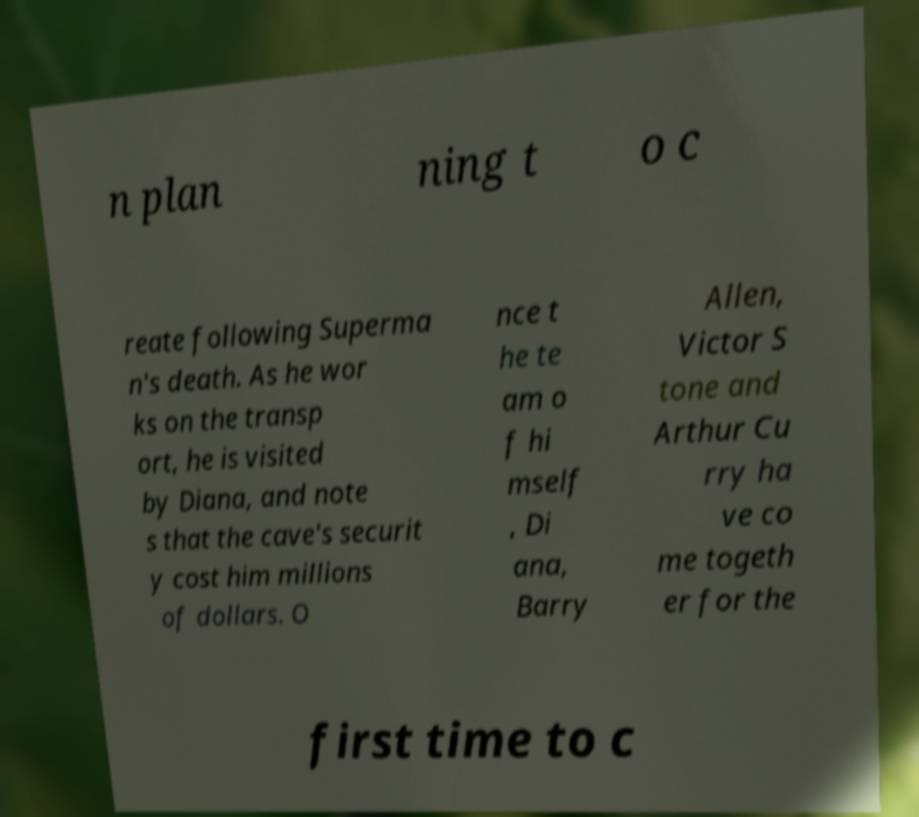What messages or text are displayed in this image? I need them in a readable, typed format. n plan ning t o c reate following Superma n's death. As he wor ks on the transp ort, he is visited by Diana, and note s that the cave's securit y cost him millions of dollars. O nce t he te am o f hi mself , Di ana, Barry Allen, Victor S tone and Arthur Cu rry ha ve co me togeth er for the first time to c 